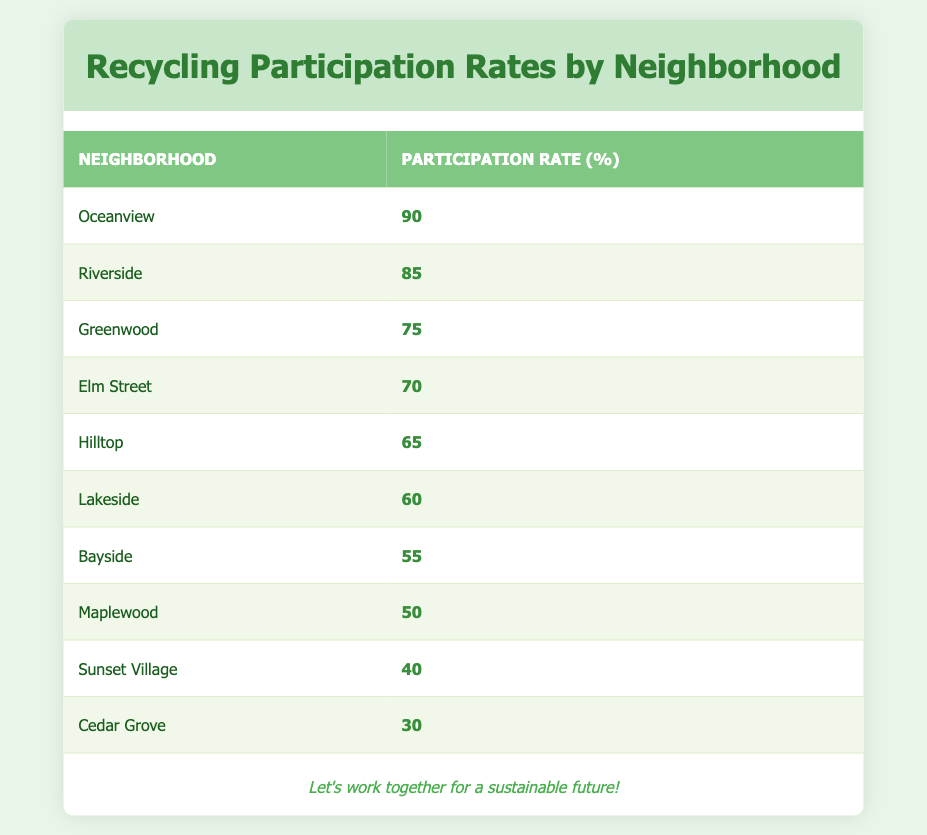What is the recycling participation rate in Oceanview? Oceanview's row in the table shows a participation rate of 90%.
Answer: 90 Which neighborhood has the lowest recycling participation rate? Looking at the table, Cedar Grove has the lowest participation rate of 30%.
Answer: Cedar Grove What is the average recycling participation rate of the neighborhoods listed? To find the average, sum all the participation rates: (90 + 85 + 75 + 70 + 65 + 60 + 55 + 50 + 40 + 30) = 720. Then divide by the number of neighborhoods, which is 10. Thus, the average rate is 720/10 = 72.
Answer: 72 Is the recycling participation rate in Hillside above 60%? The table lists Hilltop's participation rate as 65%, which is indeed above 60%.
Answer: Yes How many neighborhoods have a recycling participation rate of 60% or higher? The neighborhoods with 60% or higher participation rates are Oceanview, Riverside, Greenwood, Elm Street, and Hilltop. This totals 5 neighborhoods.
Answer: 5 What is the difference in recycling participation rates between the highest and lowest neighborhoods? The highest rate is from Oceanview at 90% and the lowest is Cedar Grove at 30%. The difference is calculated as 90 - 30 = 60.
Answer: 60 Which neighborhood has a higher recycling participation rate, Maplewood or Lakeside? Maplewood has a participation rate of 50% and Lakeside has 60%. Since 60% is greater than 50%, Lakeside has the higher rate.
Answer: Lakeside How many neighborhoods are participating in recycling at rates below 50%? The neighborhoods with participation rates below 50% are Sunset Village (40%) and Cedar Grove (30%). So there are 2 neighborhoods below this threshold.
Answer: 2 Are more than three neighborhoods achieving a participation rate over 70%? The table reveals that four neighborhoods (Oceanview, Riverside, Greenwood, and Elm Street) have rates over 70%. Therefore, this statement is true.
Answer: Yes 